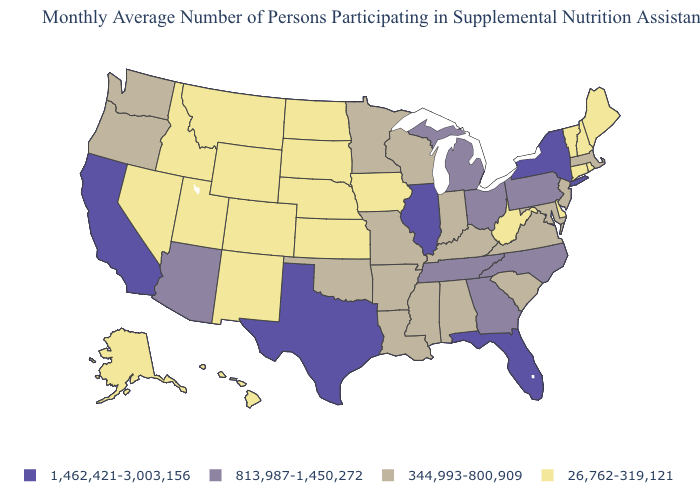Name the states that have a value in the range 813,987-1,450,272?
Answer briefly. Arizona, Georgia, Michigan, North Carolina, Ohio, Pennsylvania, Tennessee. Does the first symbol in the legend represent the smallest category?
Short answer required. No. What is the lowest value in states that border Connecticut?
Give a very brief answer. 26,762-319,121. Is the legend a continuous bar?
Be succinct. No. Which states hav the highest value in the MidWest?
Keep it brief. Illinois. Does the map have missing data?
Be succinct. No. Which states hav the highest value in the West?
Short answer required. California. Is the legend a continuous bar?
Answer briefly. No. What is the value of New Hampshire?
Keep it brief. 26,762-319,121. Name the states that have a value in the range 26,762-319,121?
Answer briefly. Alaska, Colorado, Connecticut, Delaware, Hawaii, Idaho, Iowa, Kansas, Maine, Montana, Nebraska, Nevada, New Hampshire, New Mexico, North Dakota, Rhode Island, South Dakota, Utah, Vermont, West Virginia, Wyoming. What is the value of Georgia?
Quick response, please. 813,987-1,450,272. Does Delaware have the same value as West Virginia?
Concise answer only. Yes. Does Louisiana have a lower value than Texas?
Concise answer only. Yes. Does Washington have the lowest value in the West?
Be succinct. No. What is the value of Michigan?
Answer briefly. 813,987-1,450,272. 